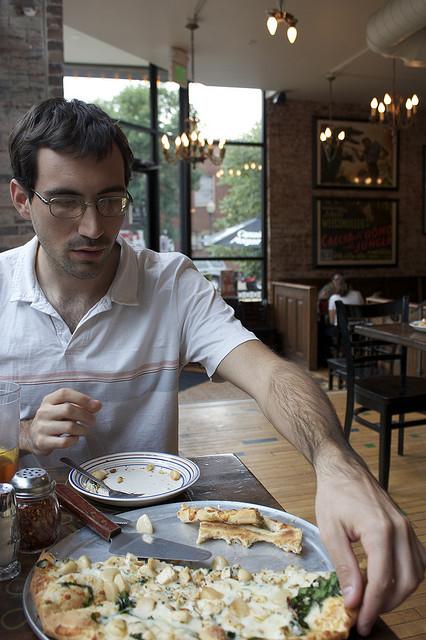Is the man balding?
Short answer required. No. What toppings are on the pizza?
Keep it brief. Spinach and chicken. What hairstyle does the man have?
Quick response, please. Short. What type of surface makes up the top of the table?
Be succinct. Wood. Does this man have a beard?
Keep it brief. No. What is the man cutting?
Concise answer only. Pizza. What is the man holding?
Short answer required. Pizza. Why is the man in the restaurant by himself eating a slice of pizza?
Answer briefly. He's hungry. Is the man angry?
Be succinct. No. Where is the used fork?
Answer briefly. Plate. What is the man eating with?
Keep it brief. Hands. Is there a dessert item on the table?
Concise answer only. No. What type of food is he eating?
Write a very short answer. Pizza. What kind of shirt is he wearing?
Give a very brief answer. Polo. 